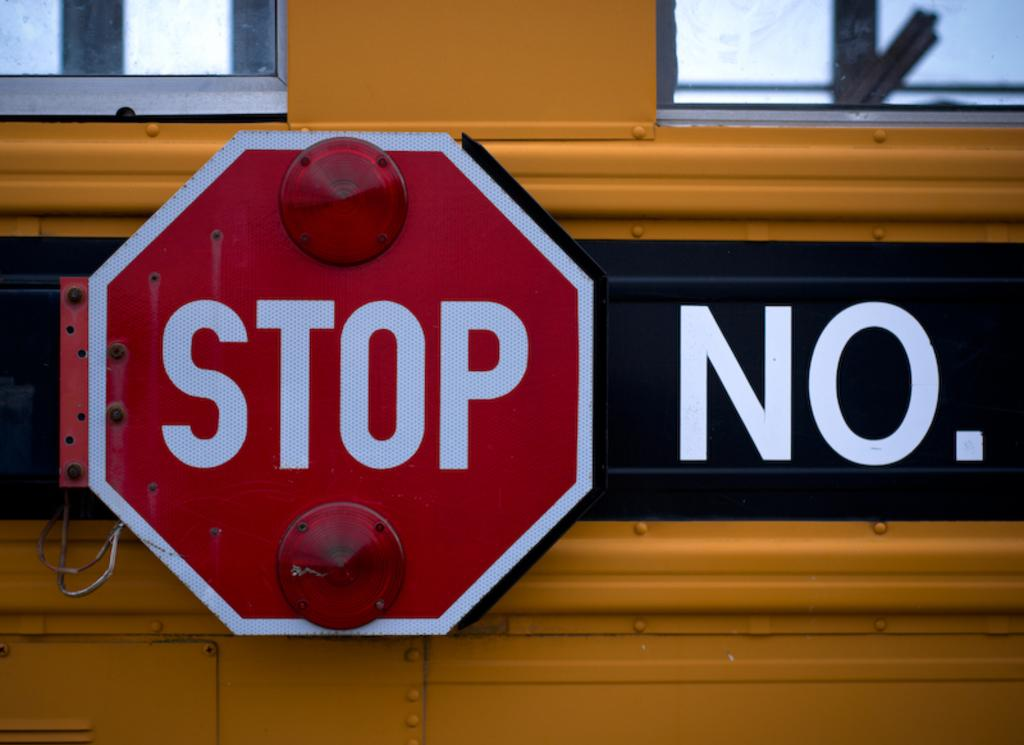<image>
Give a short and clear explanation of the subsequent image. A Stop sign attached to a yellow school bus in the closed position. 